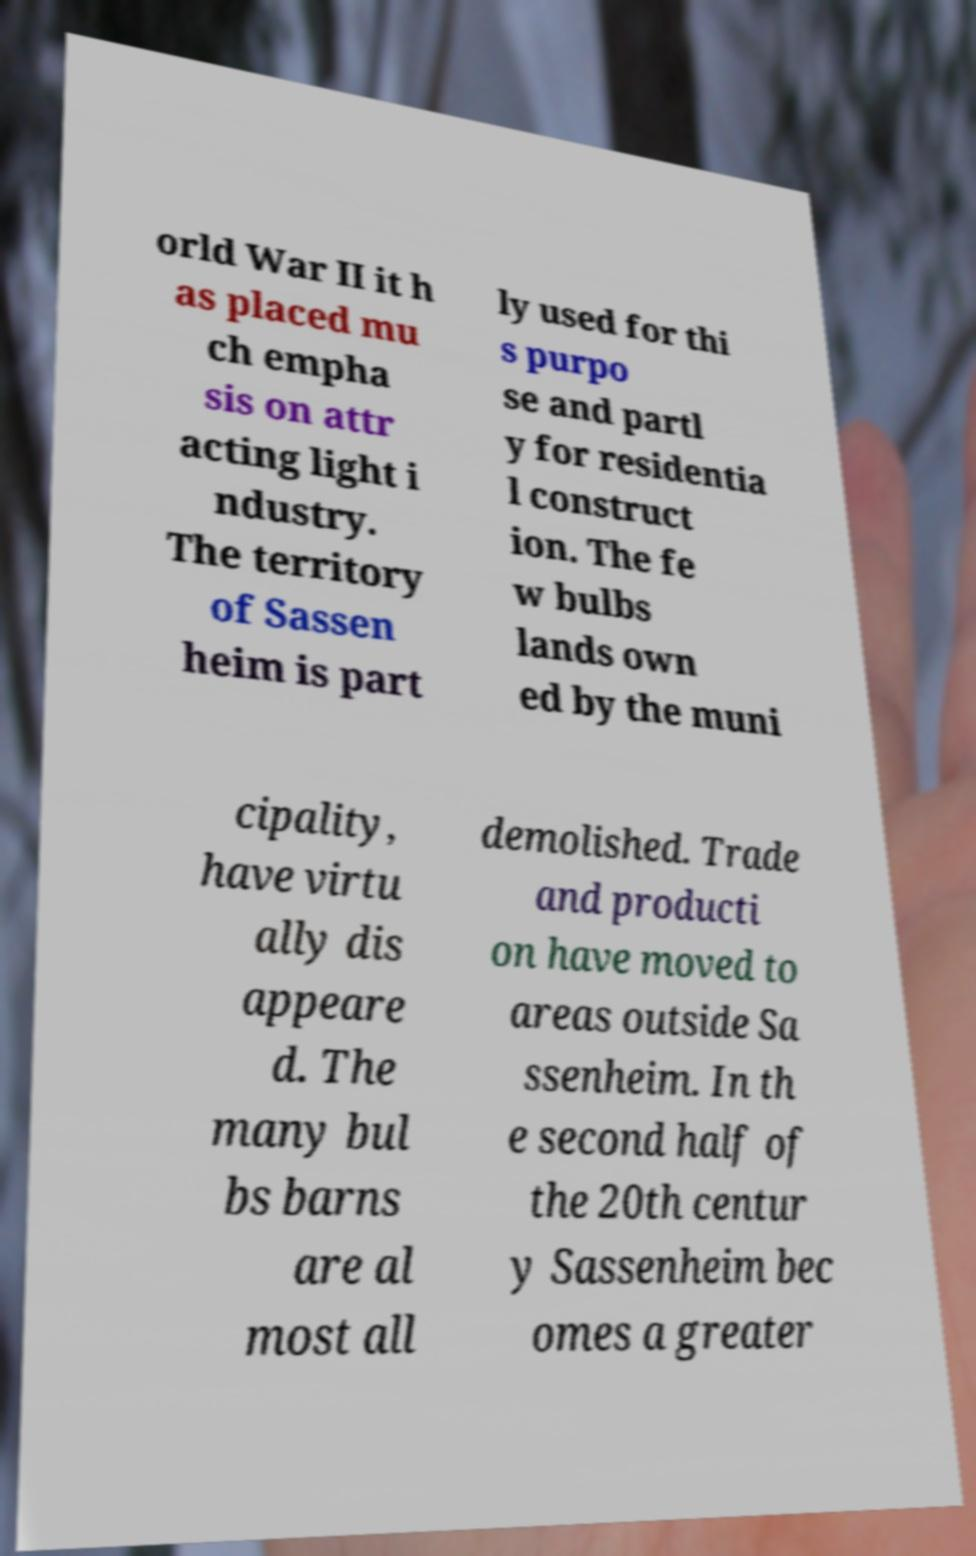What messages or text are displayed in this image? I need them in a readable, typed format. orld War II it h as placed mu ch empha sis on attr acting light i ndustry. The territory of Sassen heim is part ly used for thi s purpo se and partl y for residentia l construct ion. The fe w bulbs lands own ed by the muni cipality, have virtu ally dis appeare d. The many bul bs barns are al most all demolished. Trade and producti on have moved to areas outside Sa ssenheim. In th e second half of the 20th centur y Sassenheim bec omes a greater 